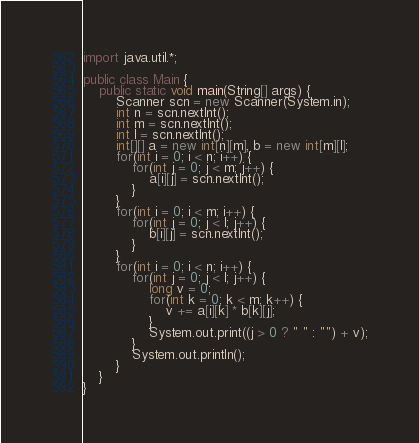Convert code to text. <code><loc_0><loc_0><loc_500><loc_500><_Java_>import java.util.*;

public class Main {
    public static void main(String[] args) {
        Scanner scn = new Scanner(System.in);
        int n = scn.nextInt();
        int m = scn.nextInt();
        int l = scn.nextInt();
        int[][] a = new int[n][m], b = new int[m][l];
        for(int i = 0; i < n; i++) {
            for(int j = 0; j < m; j++) {
                a[i][j] = scn.nextInt();
            }
        }
        for(int i = 0; i < m; i++) {
            for(int j = 0; j < l; j++) {
                b[i][j] = scn.nextInt();
            }
        }
        for(int i = 0; i < n; i++) {
            for(int j = 0; j < l; j++) {
                long v = 0;
                for(int k = 0; k < m; k++) {
                    v += a[i][k] * b[k][j];
                }
                System.out.print((j > 0 ? " " : "") + v);
            }
            System.out.println();
        }
    }
}</code> 